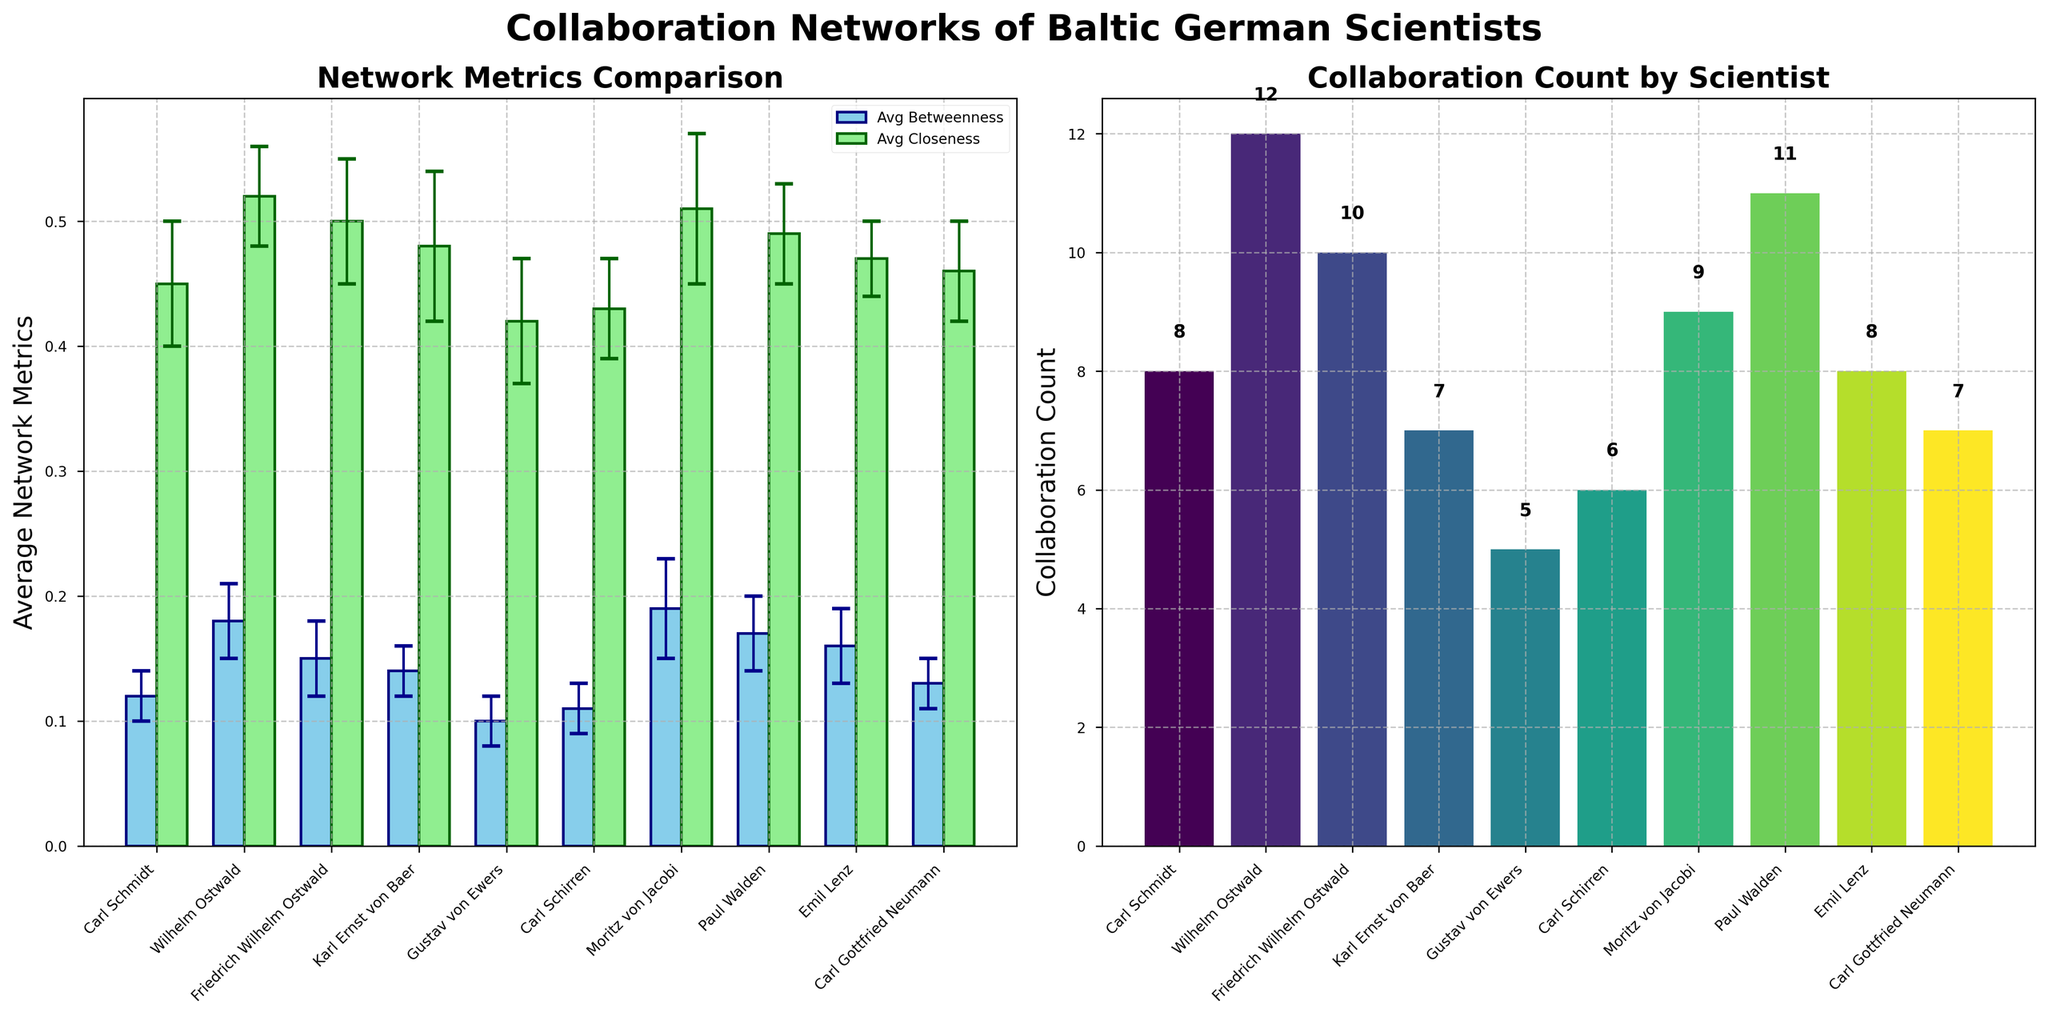What is the title of the plot? The title is displayed at the top center of the figure. It reads "Collaboration Networks of Baltic German Scientists".
Answer: Collaboration Networks of Baltic German Scientists Which scientist has the highest collaboration count? By inspecting the "Collaboration Count by Scientist" subplot, Paul Walden has the highest bar, indicating the highest collaboration count of 11.
Answer: Paul Walden What is the average betweenness of Moritz von Jacobi? In the "Network Metrics Comparison" subplot, the light blue bar for Moritz von Jacobi represents betweenness. By inspecting the height of the bar, we see it is at 0.19.
Answer: 0.19 What are the axis labels for the Network Metrics Comparison subplot? The y-axis label is "Average Network Metrics" and the x-axis ticks represent the names of the scientists. These labels can be found on the left side and bottom of the subplot, respectively.
Answer: Average Network Metrics, Scientists Which scientist has the highest average closeness score, and what is the value? Wilhelm Ostwald has the highest average closeness score as indicated by the light green bar in the "Network Metrics Comparison" subplot, with a value of 0.52.
Answer: Wilhelm Ostwald, 0.52 How does the betweenness error for Emil Lenz compare to that of Carl Schmidt? By observing the error bars in the "Network Metrics Comparison" subplot, Emil Lenz has a betweenness error of 0.03 (longer error bar) and Carl Schmidt has a betweenness error of 0.02 (shorter error bar). The betweenness error for Emil Lenz is higher.
Answer: Emil Lenz has a higher betweenness error Which institution appears most frequently among the scientists? By counting the occurrences of each institution name in the x-axis ticks, the "University of Dorpat" is the most frequently appearing institution with four scientists (Carl Schmidt, Gustav von Ewers, Carl Schirren, Carl Gottfried Neumann).
Answer: University of Dorpat Compare the collaboration counts of scientists associated with the University of Leipzig. Both Wilhelm Ostwald and Friedrich Wilhelm Ostwald are associated with the University of Leipzig and have collaboration counts of 12 and 10, respectively, as seen in the "Collaboration Count by Scientist" subplot.
Answer: Wilhelm Ostwald: 12, Friedrich Wilhelm Ostwald: 10 What is the average betweenness of all the scientists combined? To find the average, sum up all the individual betweenness values (0.12 + 0.18 + 0.15 + 0.14 + 0.10 + 0.11 + 0.19 + 0.17 + 0.16 + 0.13) = 1.45, then divide by the number of scientists (10). This results in 0.145.
Answer: 0.145 Who has a higher average network metric according to betweenness: Karl Ernst von Baer or Carl Gottfried Neumann? Comparing the average betweenness values: Karl Ernst von Baer has 0.14 and Carl Gottfried Neumann has 0.13. Therefore, Karl Ernst von Baer has the higher average betweenness.
Answer: Karl Ernst von Baer 